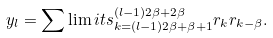<formula> <loc_0><loc_0><loc_500><loc_500>y _ { l } = \sum \lim i t s _ { k = ( l - 1 ) 2 \beta + \beta + 1 } ^ { ( l - 1 ) 2 \beta + 2 \beta } r _ { k } r _ { k - \beta } .</formula> 